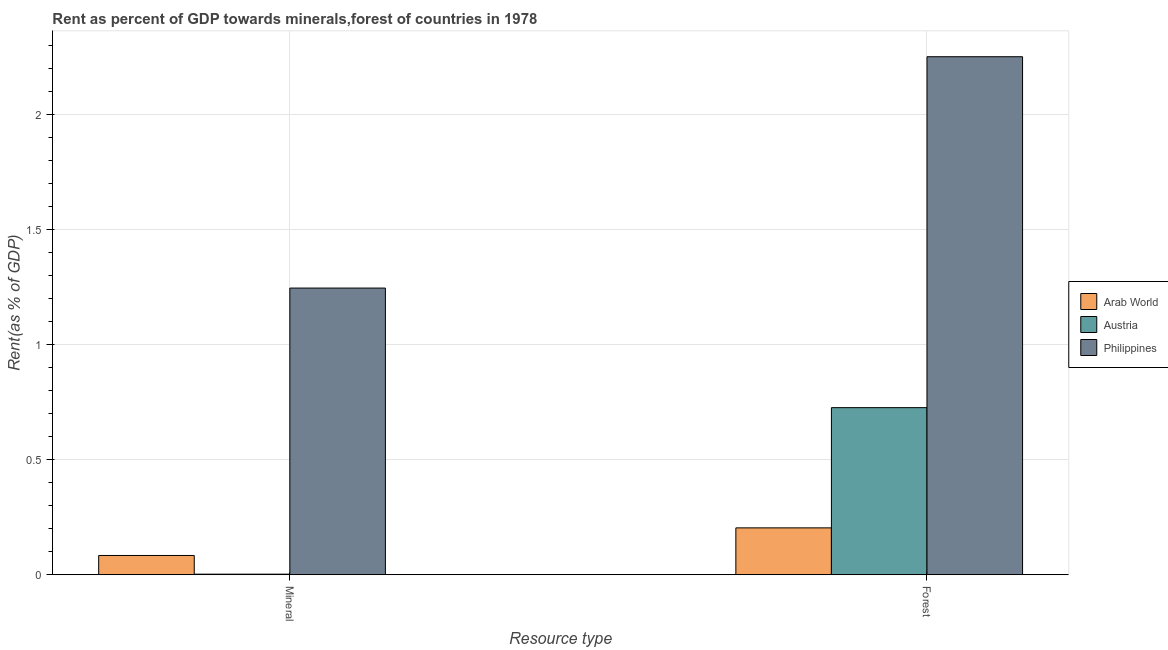How many groups of bars are there?
Keep it short and to the point. 2. Are the number of bars per tick equal to the number of legend labels?
Ensure brevity in your answer.  Yes. What is the label of the 1st group of bars from the left?
Offer a terse response. Mineral. What is the mineral rent in Austria?
Your response must be concise. 0. Across all countries, what is the maximum mineral rent?
Give a very brief answer. 1.25. Across all countries, what is the minimum forest rent?
Keep it short and to the point. 0.2. In which country was the forest rent maximum?
Your answer should be compact. Philippines. In which country was the mineral rent minimum?
Your answer should be very brief. Austria. What is the total forest rent in the graph?
Offer a terse response. 3.18. What is the difference between the forest rent in Philippines and that in Austria?
Offer a very short reply. 1.53. What is the difference between the mineral rent in Austria and the forest rent in Philippines?
Ensure brevity in your answer.  -2.25. What is the average forest rent per country?
Keep it short and to the point. 1.06. What is the difference between the forest rent and mineral rent in Arab World?
Your answer should be compact. 0.12. In how many countries, is the mineral rent greater than 1.8 %?
Provide a succinct answer. 0. What is the ratio of the mineral rent in Austria to that in Arab World?
Keep it short and to the point. 0.03. Is the forest rent in Philippines less than that in Austria?
Keep it short and to the point. No. In how many countries, is the forest rent greater than the average forest rent taken over all countries?
Ensure brevity in your answer.  1. What does the 3rd bar from the right in Forest represents?
Make the answer very short. Arab World. Are all the bars in the graph horizontal?
Offer a very short reply. No. What is the difference between two consecutive major ticks on the Y-axis?
Provide a succinct answer. 0.5. Are the values on the major ticks of Y-axis written in scientific E-notation?
Your response must be concise. No. Where does the legend appear in the graph?
Keep it short and to the point. Center right. How many legend labels are there?
Make the answer very short. 3. What is the title of the graph?
Keep it short and to the point. Rent as percent of GDP towards minerals,forest of countries in 1978. What is the label or title of the X-axis?
Offer a terse response. Resource type. What is the label or title of the Y-axis?
Provide a short and direct response. Rent(as % of GDP). What is the Rent(as % of GDP) in Arab World in Mineral?
Ensure brevity in your answer.  0.08. What is the Rent(as % of GDP) in Austria in Mineral?
Offer a terse response. 0. What is the Rent(as % of GDP) in Philippines in Mineral?
Your answer should be very brief. 1.25. What is the Rent(as % of GDP) in Arab World in Forest?
Keep it short and to the point. 0.2. What is the Rent(as % of GDP) in Austria in Forest?
Provide a short and direct response. 0.73. What is the Rent(as % of GDP) in Philippines in Forest?
Offer a very short reply. 2.25. Across all Resource type, what is the maximum Rent(as % of GDP) of Arab World?
Offer a terse response. 0.2. Across all Resource type, what is the maximum Rent(as % of GDP) in Austria?
Your answer should be compact. 0.73. Across all Resource type, what is the maximum Rent(as % of GDP) of Philippines?
Offer a very short reply. 2.25. Across all Resource type, what is the minimum Rent(as % of GDP) of Arab World?
Make the answer very short. 0.08. Across all Resource type, what is the minimum Rent(as % of GDP) in Austria?
Give a very brief answer. 0. Across all Resource type, what is the minimum Rent(as % of GDP) in Philippines?
Offer a terse response. 1.25. What is the total Rent(as % of GDP) of Arab World in the graph?
Provide a succinct answer. 0.29. What is the total Rent(as % of GDP) of Austria in the graph?
Make the answer very short. 0.73. What is the total Rent(as % of GDP) in Philippines in the graph?
Keep it short and to the point. 3.5. What is the difference between the Rent(as % of GDP) of Arab World in Mineral and that in Forest?
Your response must be concise. -0.12. What is the difference between the Rent(as % of GDP) in Austria in Mineral and that in Forest?
Make the answer very short. -0.72. What is the difference between the Rent(as % of GDP) of Philippines in Mineral and that in Forest?
Give a very brief answer. -1.01. What is the difference between the Rent(as % of GDP) in Arab World in Mineral and the Rent(as % of GDP) in Austria in Forest?
Your answer should be compact. -0.64. What is the difference between the Rent(as % of GDP) of Arab World in Mineral and the Rent(as % of GDP) of Philippines in Forest?
Provide a succinct answer. -2.17. What is the difference between the Rent(as % of GDP) in Austria in Mineral and the Rent(as % of GDP) in Philippines in Forest?
Offer a very short reply. -2.25. What is the average Rent(as % of GDP) of Arab World per Resource type?
Provide a succinct answer. 0.14. What is the average Rent(as % of GDP) of Austria per Resource type?
Your answer should be very brief. 0.36. What is the average Rent(as % of GDP) of Philippines per Resource type?
Provide a succinct answer. 1.75. What is the difference between the Rent(as % of GDP) of Arab World and Rent(as % of GDP) of Austria in Mineral?
Offer a very short reply. 0.08. What is the difference between the Rent(as % of GDP) of Arab World and Rent(as % of GDP) of Philippines in Mineral?
Your answer should be very brief. -1.16. What is the difference between the Rent(as % of GDP) of Austria and Rent(as % of GDP) of Philippines in Mineral?
Provide a short and direct response. -1.24. What is the difference between the Rent(as % of GDP) in Arab World and Rent(as % of GDP) in Austria in Forest?
Your answer should be compact. -0.52. What is the difference between the Rent(as % of GDP) in Arab World and Rent(as % of GDP) in Philippines in Forest?
Your answer should be very brief. -2.05. What is the difference between the Rent(as % of GDP) of Austria and Rent(as % of GDP) of Philippines in Forest?
Offer a very short reply. -1.53. What is the ratio of the Rent(as % of GDP) in Arab World in Mineral to that in Forest?
Give a very brief answer. 0.41. What is the ratio of the Rent(as % of GDP) of Austria in Mineral to that in Forest?
Provide a short and direct response. 0. What is the ratio of the Rent(as % of GDP) of Philippines in Mineral to that in Forest?
Make the answer very short. 0.55. What is the difference between the highest and the second highest Rent(as % of GDP) of Arab World?
Offer a very short reply. 0.12. What is the difference between the highest and the second highest Rent(as % of GDP) of Austria?
Make the answer very short. 0.72. What is the difference between the highest and the second highest Rent(as % of GDP) in Philippines?
Ensure brevity in your answer.  1.01. What is the difference between the highest and the lowest Rent(as % of GDP) of Arab World?
Provide a short and direct response. 0.12. What is the difference between the highest and the lowest Rent(as % of GDP) in Austria?
Give a very brief answer. 0.72. What is the difference between the highest and the lowest Rent(as % of GDP) in Philippines?
Your answer should be very brief. 1.01. 